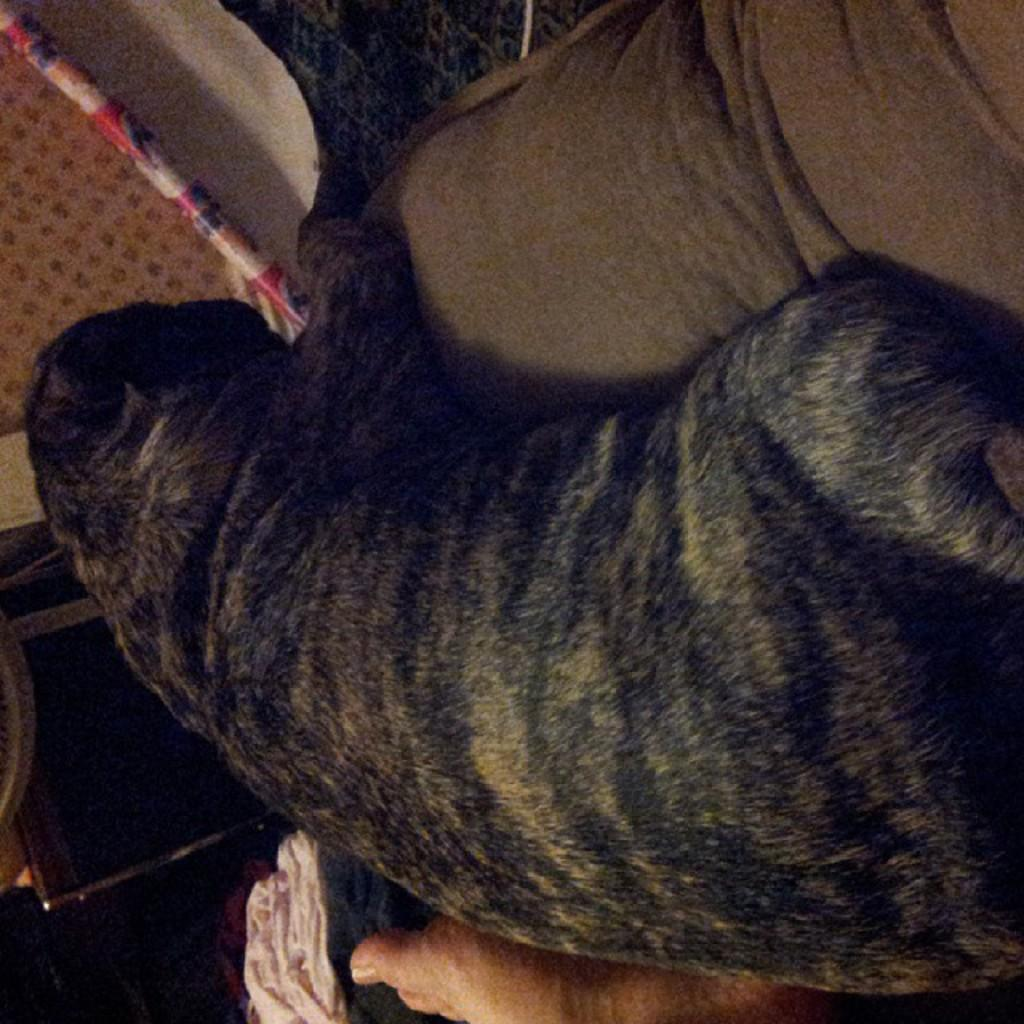What type of animal is in the image? There is an animal in the image, but the specific type cannot be determined from the provided facts. Where is the animal located in the image? The animal is on a couch in the image. What colors can be seen on the animal? The animal is in black and gray color. What is the color of the couch? The couch is in brown color. What can be seen in the background of the image? There is a multi-color stick in the background of the image. How does the animal use the brake while sitting on the couch in the image? There is no brake present in the image, as it is a photograph and not a vehicle. 